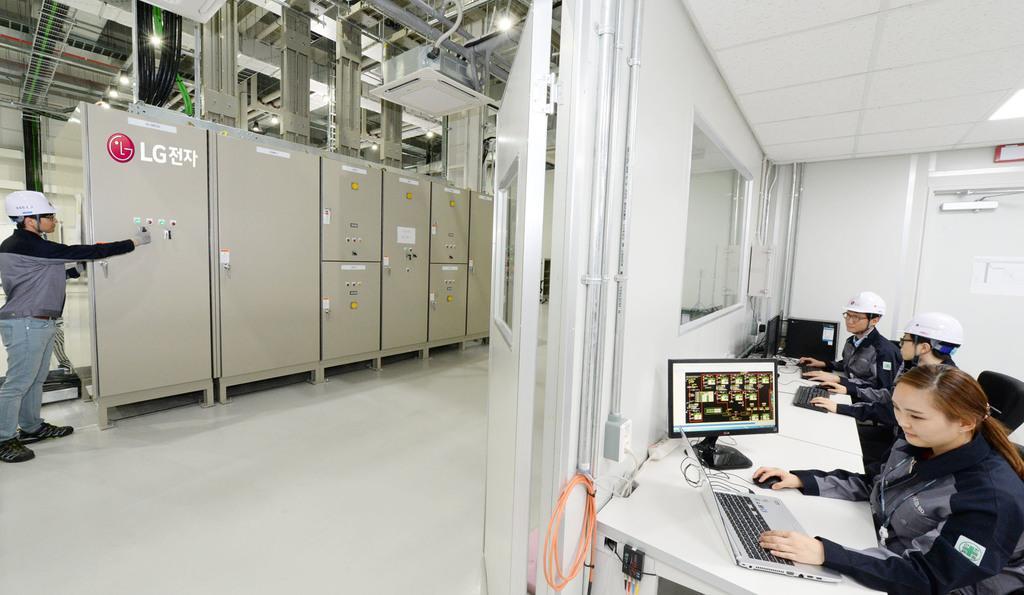Can you describe this image briefly? In this image, we can see walls, glass window, doors, poster, some objects, machines, pipes, pillars and light. Here we can see laptop, monitors, keyboards and mouses. On the left side of the image, we can see a person is standing and holding an object. 